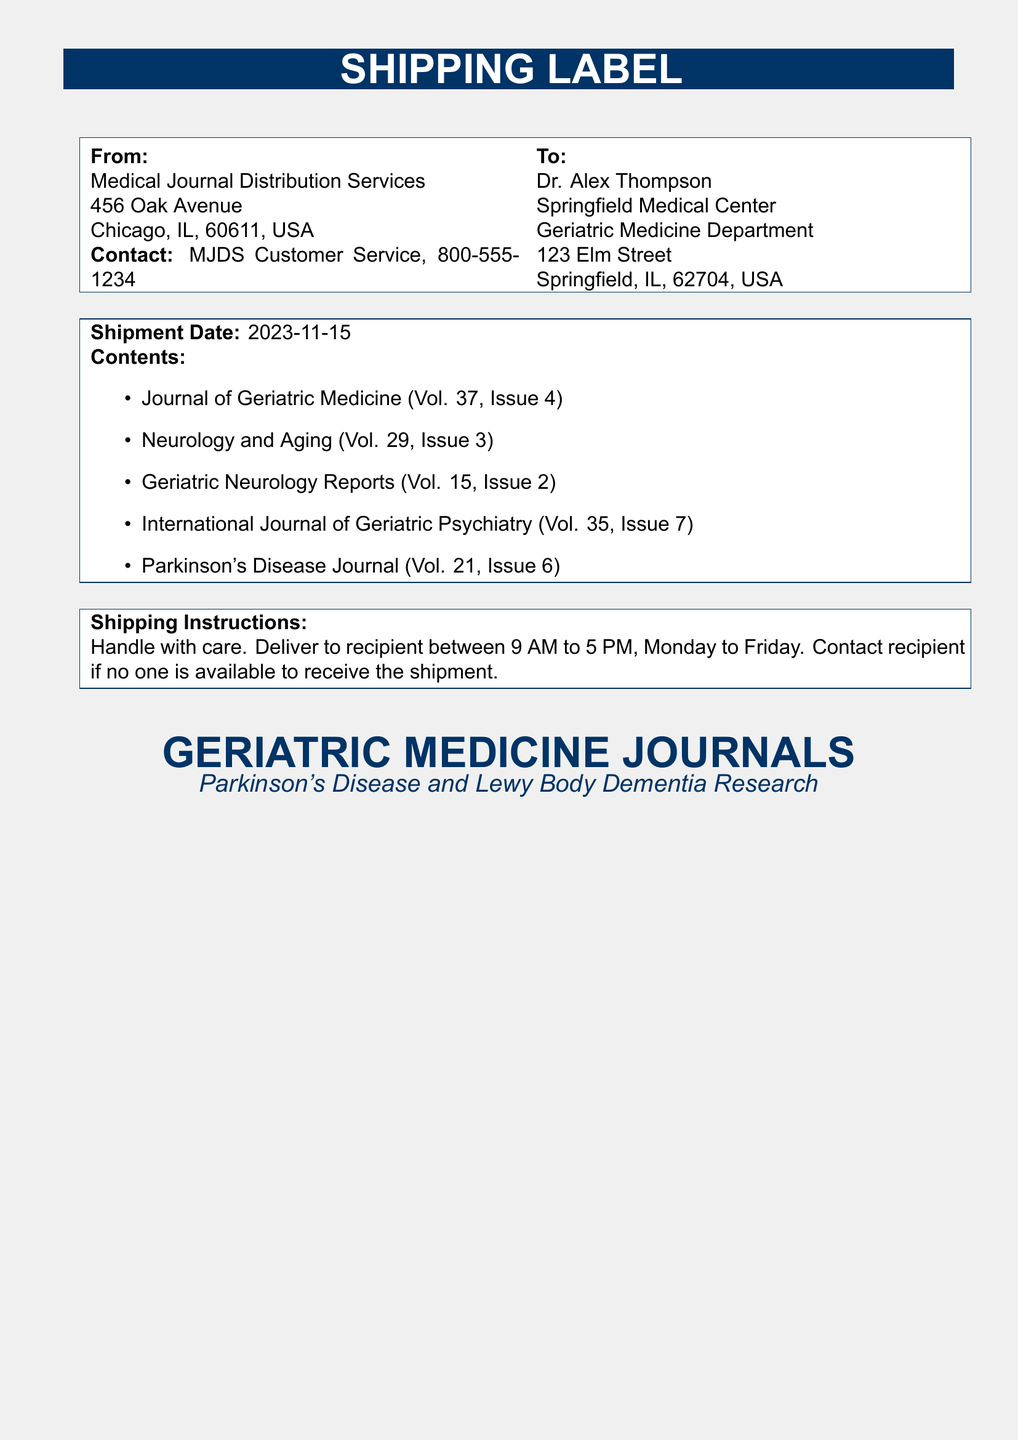What is the shipping date? The shipping date is specified in the document under 'Shipment Date.'
Answer: 2023-11-15 Who is the recipient? The document provides the name of the recipient under 'To.'
Answer: Dr. Alex Thompson What is the address of the sender? The address of the sender is listed in the 'From' section of the document.
Answer: 456 Oak Avenue, Chicago, IL, 60611, USA How many journals are listed in the shipment? The number of journals can be counted from the 'Contents' section of the document.
Answer: 5 What should be done if no one is available to receive the shipment? The document outlines instructions regarding logistical handling under 'Shipping Instructions.'
Answer: Contact recipient What is the primary focus of the journals? The title and forward descriptions help determine the focus of the journals in the shipment.
Answer: Parkinson's Disease and Lewy Body Dementia Research What are the operating hours for delivery? The specific hours for delivery are mentioned in the 'Shipping Instructions' section of the label.
Answer: 9 AM to 5 PM, Monday to Friday Which journal is specifically dedicated to Parkinson's disease? The titles listed in the 'Contents' section include details about specific journals focused on Parkinson's disease.
Answer: Parkinson's Disease Journal 